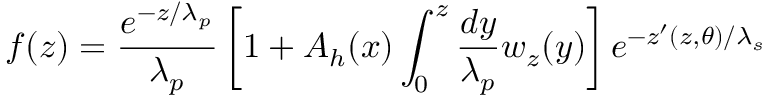<formula> <loc_0><loc_0><loc_500><loc_500>f ( z ) = \frac { e ^ { - z / \lambda _ { p } } } { \lambda _ { p } } \left [ 1 + A _ { h } ( x ) \int _ { 0 } ^ { z } \frac { d y } { \lambda _ { p } } w _ { z } ( y ) \right ] e ^ { - z ^ { \prime } ( z , \theta ) / \lambda _ { s } }</formula> 